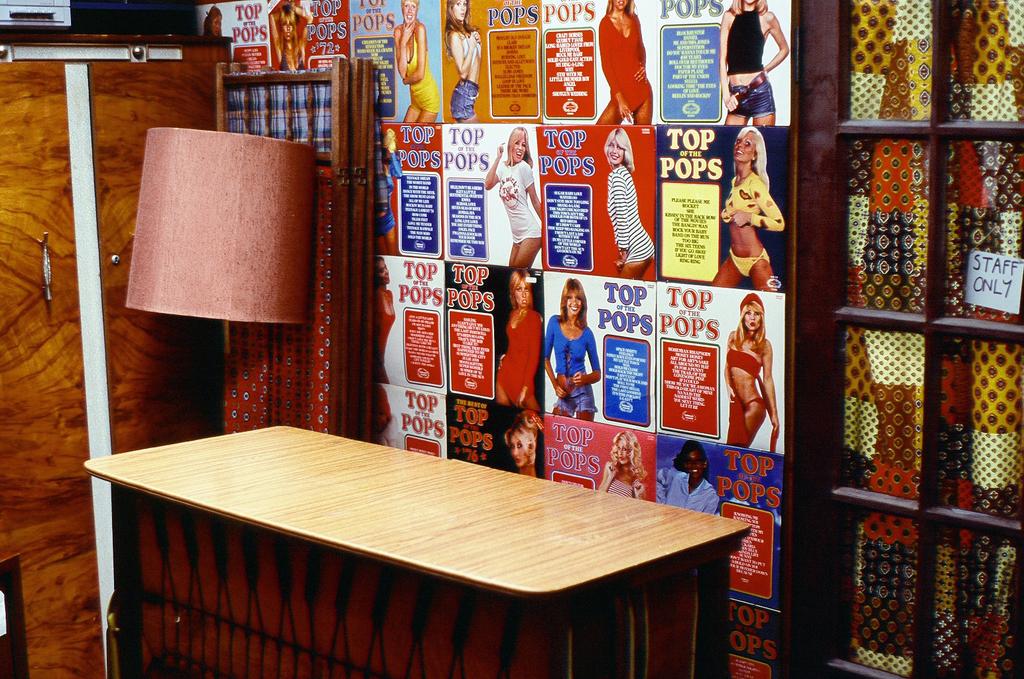Are those top pops magazines?
Ensure brevity in your answer.  Yes. 